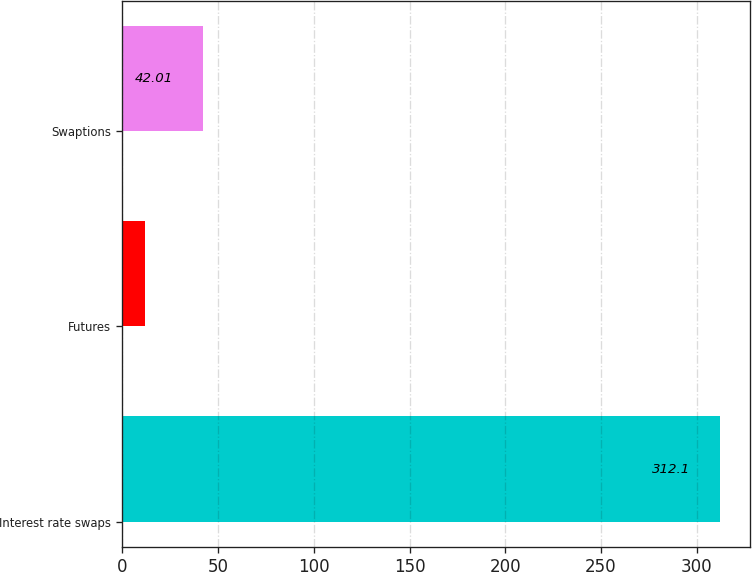Convert chart. <chart><loc_0><loc_0><loc_500><loc_500><bar_chart><fcel>Interest rate swaps<fcel>Futures<fcel>Swaptions<nl><fcel>312.1<fcel>12<fcel>42.01<nl></chart> 